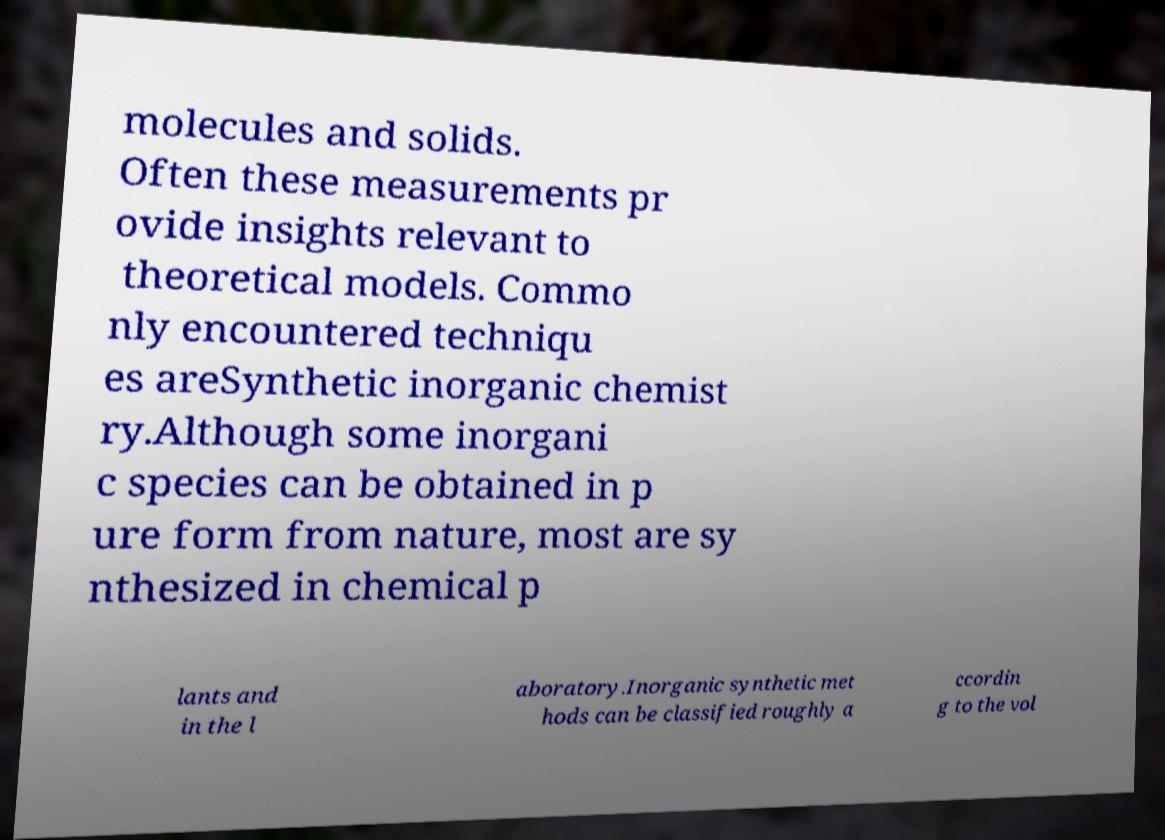There's text embedded in this image that I need extracted. Can you transcribe it verbatim? molecules and solids. Often these measurements pr ovide insights relevant to theoretical models. Commo nly encountered techniqu es areSynthetic inorganic chemist ry.Although some inorgani c species can be obtained in p ure form from nature, most are sy nthesized in chemical p lants and in the l aboratory.Inorganic synthetic met hods can be classified roughly a ccordin g to the vol 